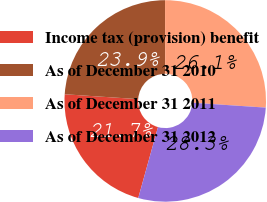<chart> <loc_0><loc_0><loc_500><loc_500><pie_chart><fcel>Income tax (provision) benefit<fcel>As of December 31 2010<fcel>As of December 31 2011<fcel>As of December 31 2012<nl><fcel>21.74%<fcel>23.91%<fcel>26.09%<fcel>28.26%<nl></chart> 